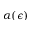<formula> <loc_0><loc_0><loc_500><loc_500>\alpha ( \epsilon )</formula> 